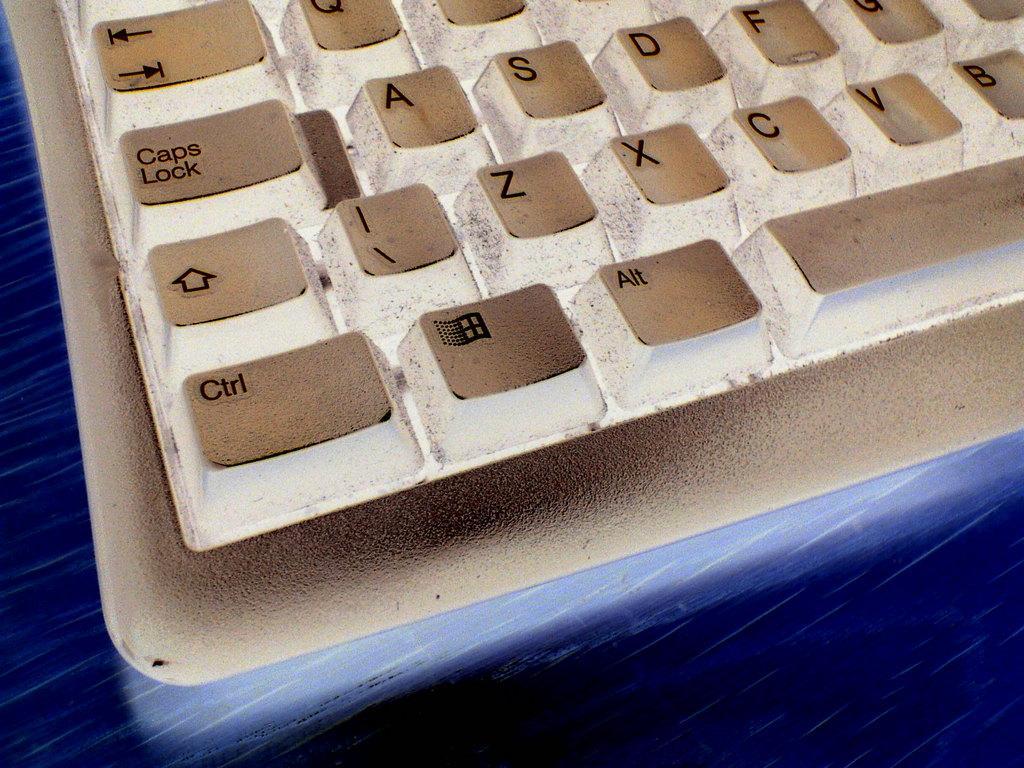Could you give a brief overview of what you see in this image? In this image I can see there is a keyboard in white color. 